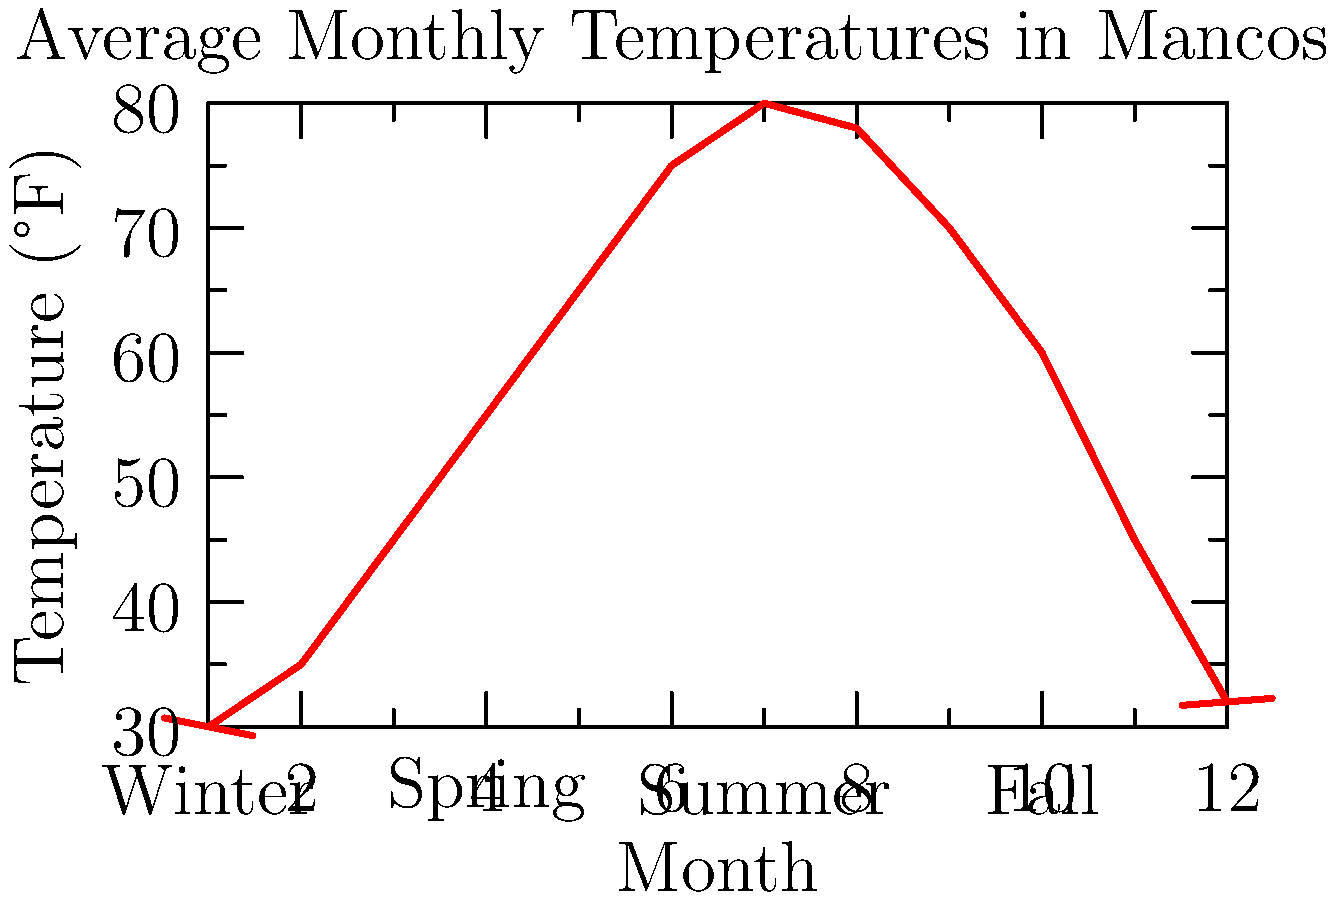Based on the line graph showing average monthly temperatures in Mancos, which season experiences the most dramatic temperature change? To determine which season experiences the most dramatic temperature change in Mancos, we need to analyze the temperature differences within each season:

1. Winter (December, January, February):
   December: 32°F, January: 30°F, February: 35°F
   Temperature range: 35°F - 30°F = 5°F

2. Spring (March, April, May):
   March: 45°F, April: 55°F, May: 65°F
   Temperature range: 65°F - 45°F = 20°F

3. Summer (June, July, August):
   June: 75°F, July: 80°F, August: 78°F
   Temperature range: 80°F - 75°F = 5°F

4. Fall (September, October, November):
   September: 70°F, October: 60°F, November: 45°F
   Temperature range: 70°F - 45°F = 25°F

Comparing the temperature ranges:
Winter: 5°F
Spring: 20°F
Summer: 5°F
Fall: 25°F

The season with the largest temperature range, and thus the most dramatic temperature change, is Fall with a 25°F difference between its warmest and coolest months.
Answer: Fall 